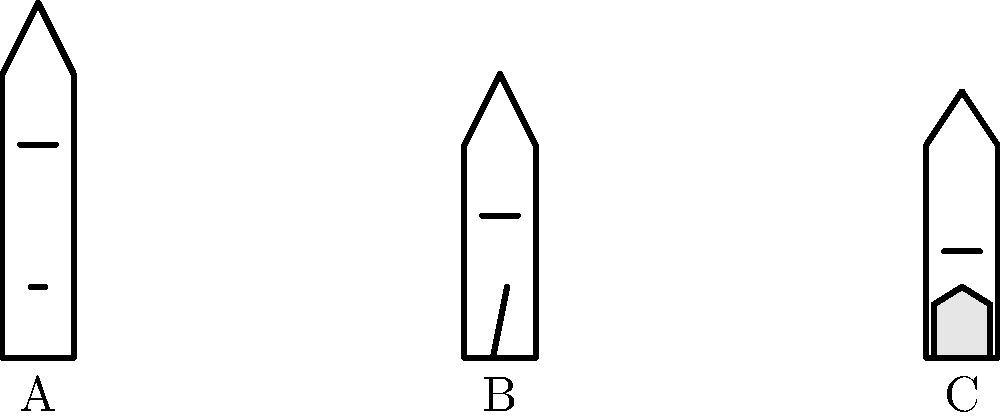Match the following architectural styles to the corresponding church images (A, B, or C):

1. Gothic Revival
2. Colonial
3. Greek Revival To match the architectural styles to the church images, let's analyze each style and image:

1. Gothic Revival:
   - Characterized by pointed arches, tall spires, and large windows
   - Image A shows these features with a tall, pointed roof and a large window

2. Colonial:
   - Simple, symmetrical design with a rectangular shape
   - Often features a central tower or steeple
   - Image B displays these characteristics with its simple, symmetrical structure and central steeple

3. Greek Revival:
   - Inspired by ancient Greek temples
   - Features columns or pilasters, often with a triangular pediment
   - Image C shows a portico (entrance porch) with columns, typical of Greek Revival style

Therefore, the correct matches are:
1. Gothic Revival - A
2. Colonial - B
3. Greek Revival - C
Answer: 1-A, 2-B, 3-C 